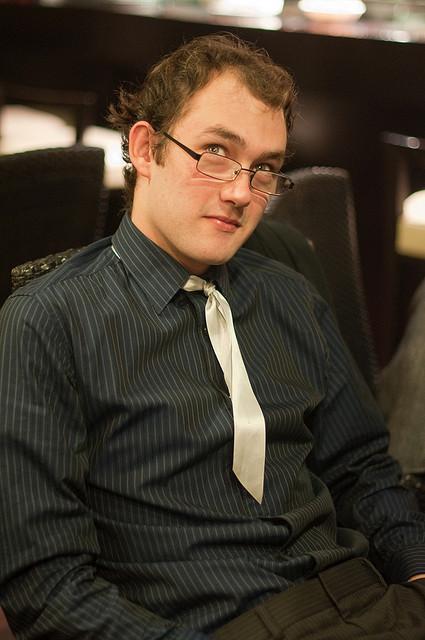How many chairs are there?
Give a very brief answer. 3. 